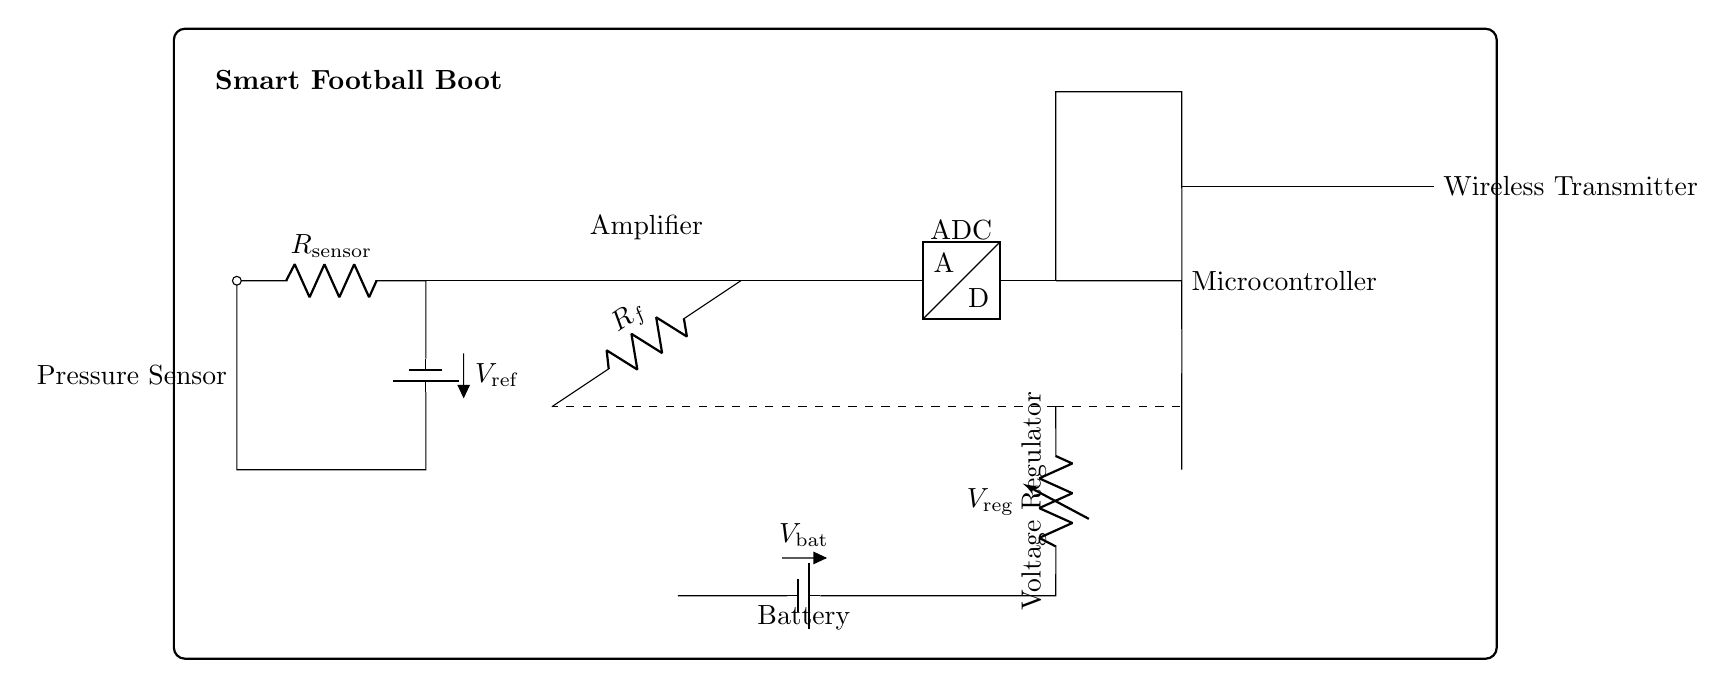What is the type of the component labeled as "Amplifier"? The component labeled as "Amplifier" in the circuit diagram is an operational amplifier, abbreviated as op amp. This is indicated by the symbol and the notation next to it.
Answer: operational amplifier What is the purpose of the "Pressure Sensor"? The purpose of the "Pressure Sensor" is to detect the pressure applied by the user's foot on the smart football boot. This information is essential for monitoring the player's performance and comfort.
Answer: detect pressure What is the supply voltage for the microcontroller? The supply voltage for the microcontroller is the regulated voltage labeled as "V_reg," which is derived from the battery voltage. This helps ensure the microcontroller operates at the required voltage level for its function.
Answer: V_reg Which component provides power to the circuit? The component providing power to the circuit is the battery labeled as "V_bat." It supplies the necessary electrical energy to the entire circuit for its operation.
Answer: V_bat How many resistors are present in the circuit? There are two resistors present in the circuit: one connected to the pressure sensor (R_sensor) and one used as feedback in the amplifier (R_f).
Answer: 2 What is the role of the wireless transmitter in this circuit? The role of the wireless transmitter is to send the data collected from the pressure sensor and processed by the microcontroller wirelessly to another device. This enables real-time data monitoring and analysis.
Answer: send data What does the term "ADC" stand for in the circuit? "ADC" stands for Analog-to-Digital Converter. This component converts the analog signals from the pressure sensor into digital signals that can be processed by the microcontroller.
Answer: Analog-to-Digital Converter 